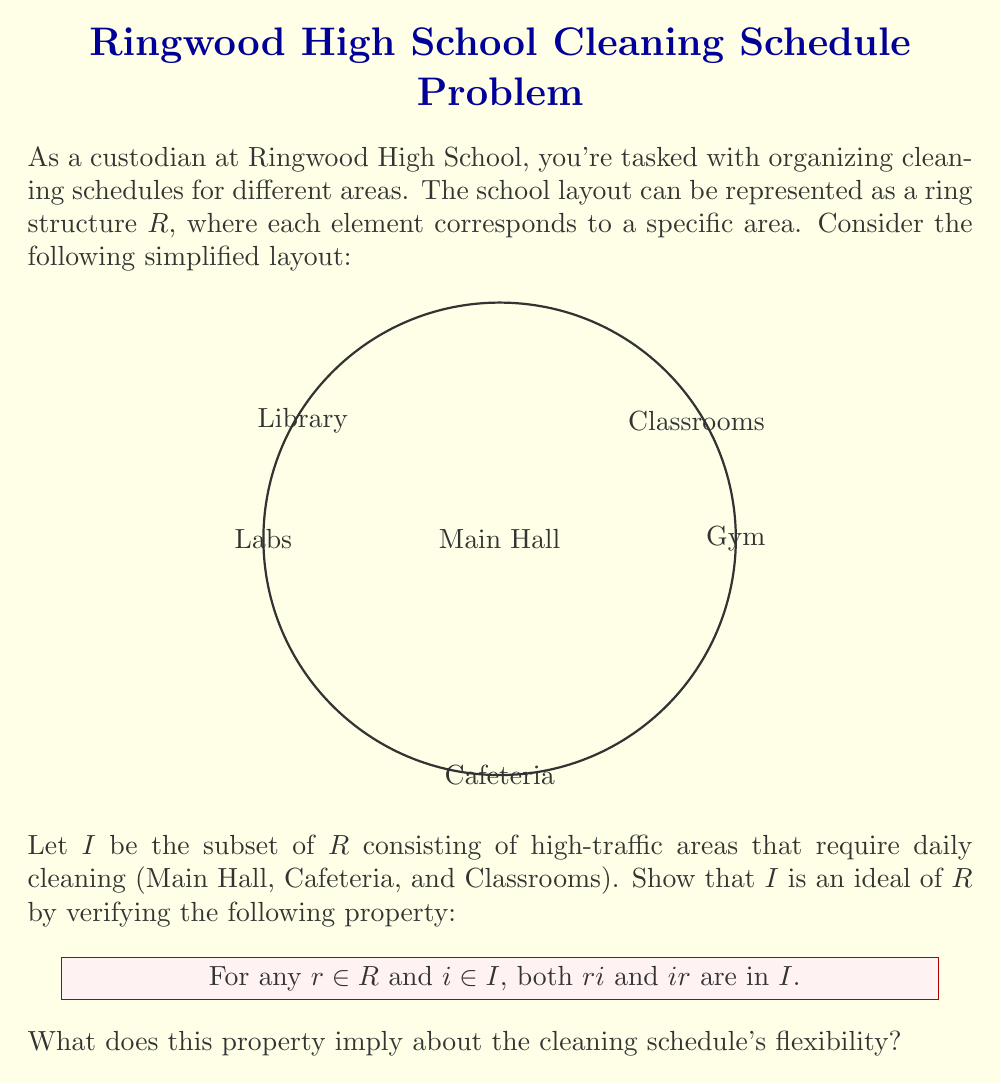What is the answer to this math problem? Let's approach this step-by-step:

1) First, recall that for $I$ to be an ideal of ring $R$, it must satisfy two properties:
   a) $I$ is a subgroup of $(R,+)$
   b) For all $r \in R$ and $i \in I$, both $ri \in I$ and $ir \in I$

2) We're asked to focus on property (b), which ensures closure under multiplication by ring elements.

3) In our context:
   - $R$ represents all areas of the school
   - $I$ represents high-traffic areas (Main Hall, Cafeteria, Classrooms)
   - "Multiplication" can be interpreted as combining cleaning tasks

4) Let's consider some examples:
   - If $r$ = Library and $i$ = Main Hall, then $ri$ and $ir$ represent cleaning tasks that involve both areas. These combined tasks would still prioritize the Main Hall (an element of $I$).
   - If $r$ = Gym and $i$ = Cafeteria, the combined task would still include the Cafeteria (an element of $I$).

5) This property ensures that no matter how we combine cleaning tasks from $I$ with tasks from the rest of the school, the result always includes the high-priority areas in $I$.

6) For the cleaning schedule, this implies:
   - High-traffic areas (elements of $I$) will always be included in any combined cleaning task.
   - The schedule is flexible: you can combine cleaning of high-traffic areas with any other area without losing focus on the priority spaces.
   - It allows for efficient planning: any staff member assigned to a high-traffic area can also cover adjacent spaces without compromising the daily cleaning of essential areas.
Answer: The ideal property ensures that high-traffic areas are always included in combined cleaning tasks, allowing for flexible and efficient scheduling. 